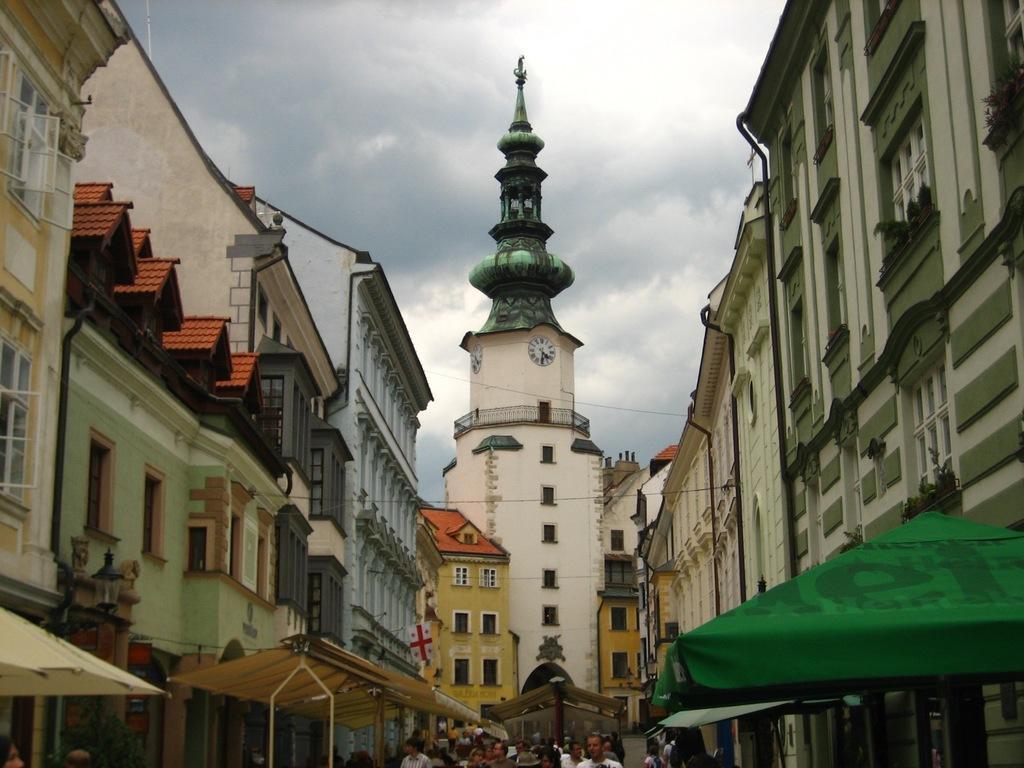Please provide a concise description of this image. At the bottom of the image there are people and we can see buildings. On the right there is a tent. In the background there is sky. 